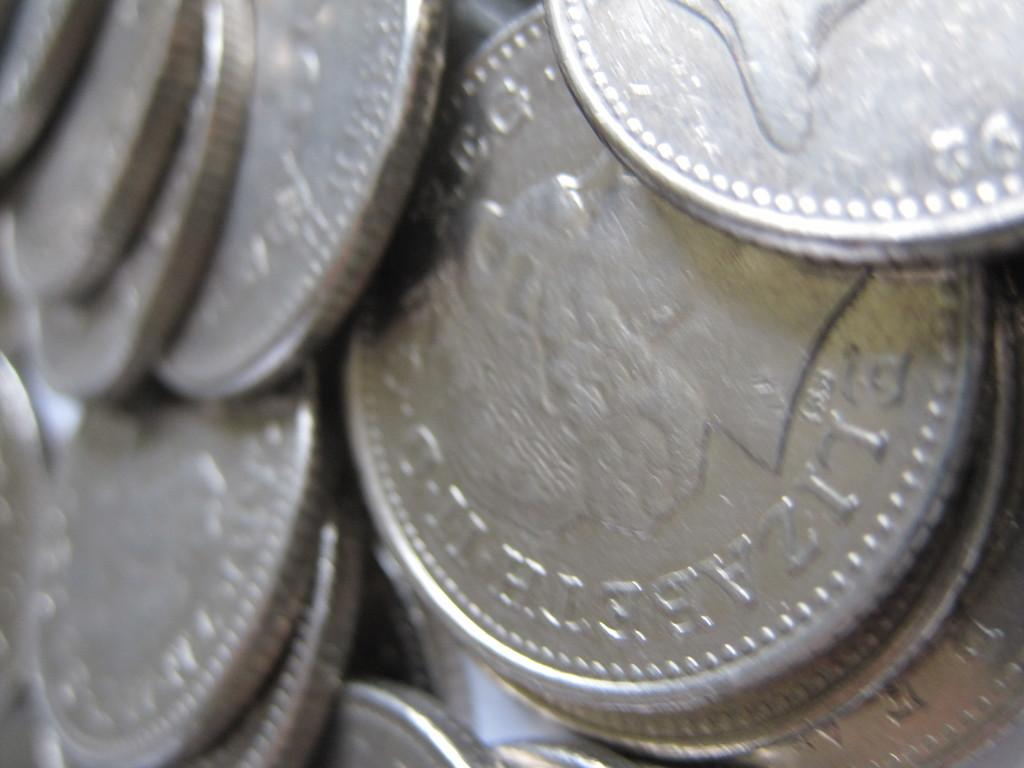What is the main subject of the image? The main subject of the image is a collection of many coins. Can you describe the arrangement of the coins in the image? The coins are located in the center of the image. What type of cable is connected to the elbow in the image? There is no cable or elbow present in the image; it only features a collection of coins. 